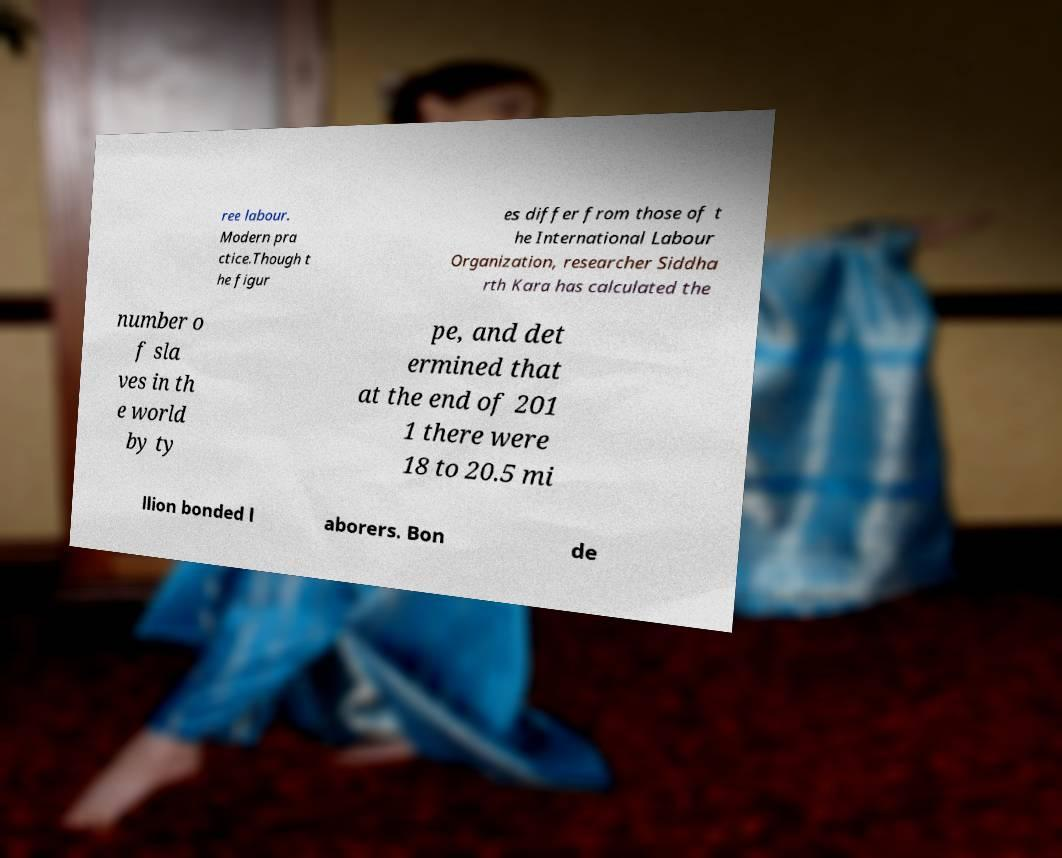Can you read and provide the text displayed in the image?This photo seems to have some interesting text. Can you extract and type it out for me? ree labour. Modern pra ctice.Though t he figur es differ from those of t he International Labour Organization, researcher Siddha rth Kara has calculated the number o f sla ves in th e world by ty pe, and det ermined that at the end of 201 1 there were 18 to 20.5 mi llion bonded l aborers. Bon de 